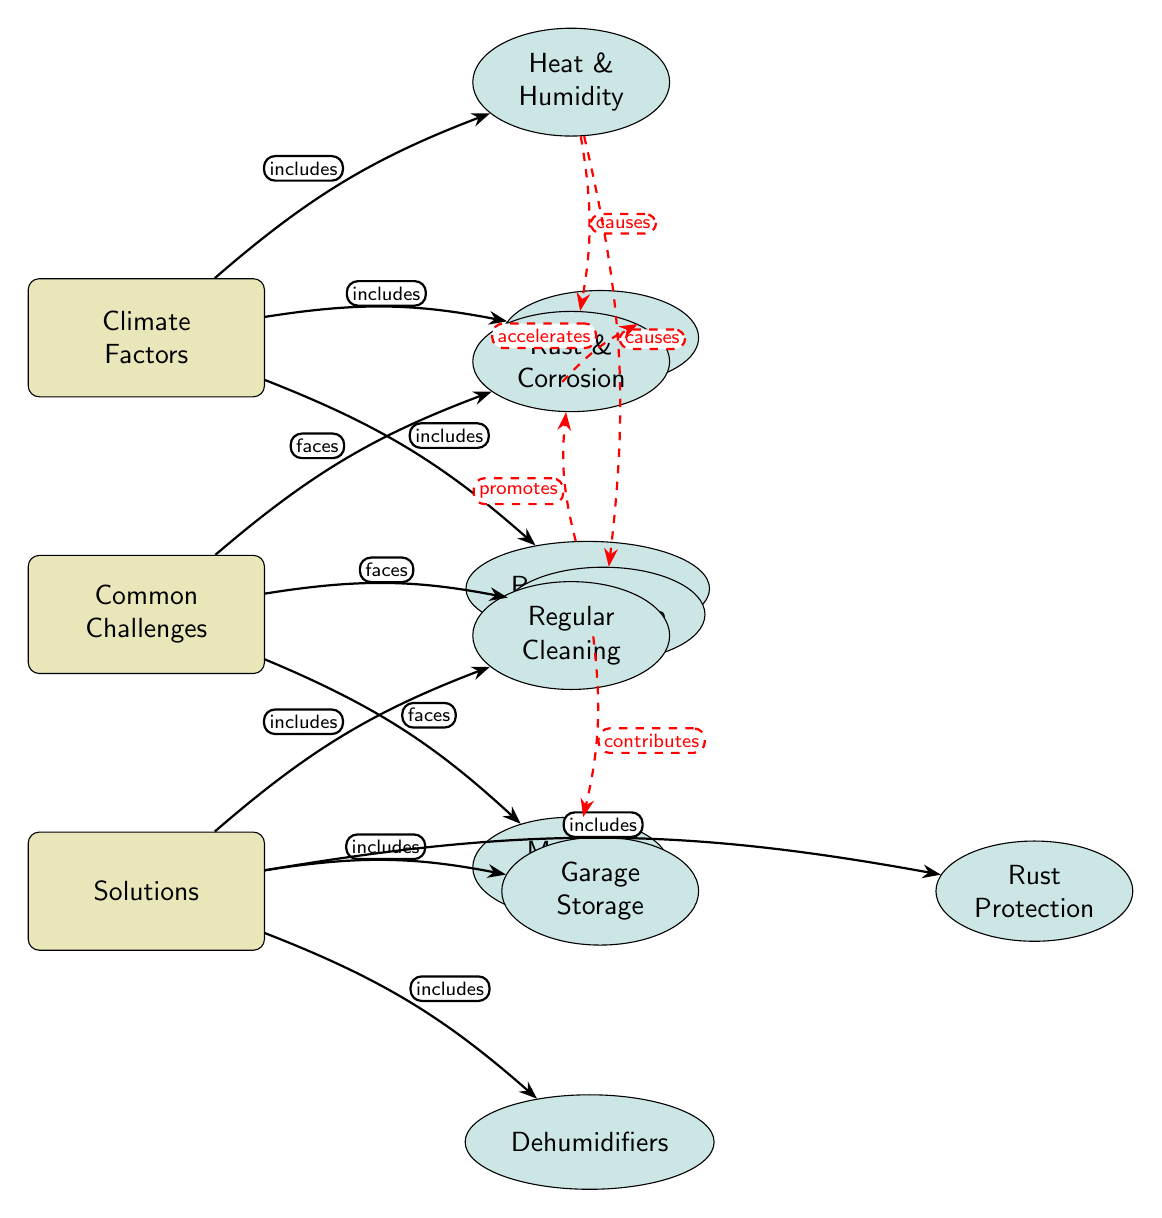What are the main climate factors affecting classic car maintenance? The diagram shows three main climate factors: Heat & Humidity, Salt Air, and Rainy Season, which are positioned directly linked to the "Climate Factors" node.
Answer: Heat & Humidity, Salt Air, Rainy Season How many common challenges are identified in the diagram? There are three challenges listed that stem from the "Common Challenges" node: Rust & Corrosion, Paint Fade, and Mold & Mildew. So, by counting the nodes in this section, we find three challenges.
Answer: 3 Which challenge is caused by heat according to the diagram? The dashed edges indicate causal relationships, and both Rust and Paint Fade are shown to be caused by Heat & Humidity. Therefore, all challenges directly connected to Heat & Humidity are causally linked to it.
Answer: Rust, Paint Fade What is a solution included in the solutions node? In the "Solutions" section, the nodes listed are Regular Cleaning, Garage Storage, Dehumidifiers, and Rust Protection, any of which could be considered a valid solution. Simply providing one of these options suffices to answer the question.
Answer: Regular Cleaning Which challenge is associated with the Rainy Season? According to the diagram, the Rainy Season has dashed edges that indicate it promotes Rust and contributes to Mold, showing the relationships with the challenges. Therefore, either Rust or Mold can be listed as an associated challenge.
Answer: Rust, Mold What does Salt Air accelerate? The diagram indicates that Salt Air has a causal relationship with Rust, shown by the dashed edge labeled "accelerates." This means that Salt Air is involved in increasing the rate of Rust formation in classic cars.
Answer: Rust Which solutions include storage methods? By examining the "Solutions" node, Garage Storage is the solution specifically regarding storage methods, while Regular Cleaning and Dehumidifiers serve different purposes. Thus, this is the primary storage-related solution listed.
Answer: Garage Storage How many relationships link climate factors to common challenges? The "Climate Factors" node connects to the "Common Challenges" via multiple dashed edges. Specifically, all three climate factors contribute to various challenges, indicating multiple direct relationships counted in total as four.
Answer: 4 